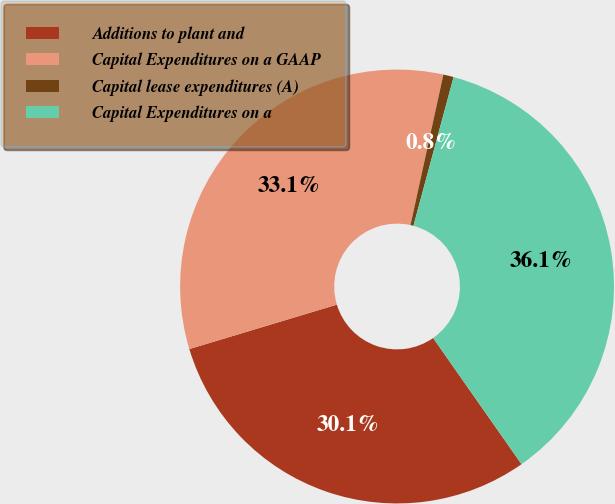Convert chart to OTSL. <chart><loc_0><loc_0><loc_500><loc_500><pie_chart><fcel>Additions to plant and<fcel>Capital Expenditures on a GAAP<fcel>Capital lease expenditures (A)<fcel>Capital Expenditures on a<nl><fcel>30.07%<fcel>33.08%<fcel>0.77%<fcel>36.08%<nl></chart> 